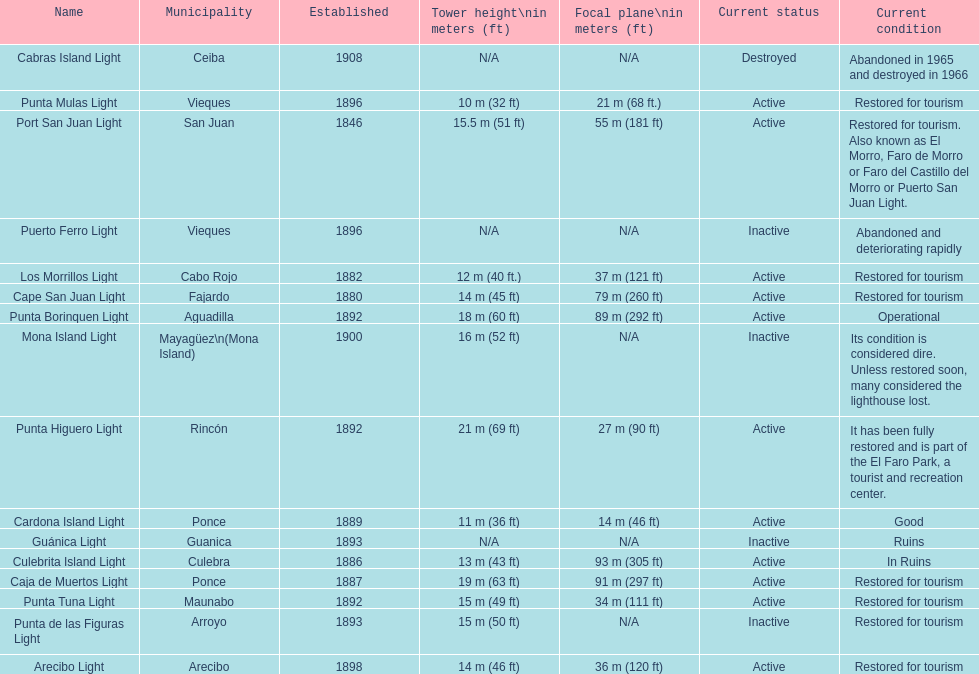Could you parse the entire table? {'header': ['Name', 'Municipality', 'Established', 'Tower height\\nin meters (ft)', 'Focal plane\\nin meters (ft)', 'Current status', 'Current condition'], 'rows': [['Cabras Island Light', 'Ceiba', '1908', 'N/A', 'N/A', 'Destroyed', 'Abandoned in 1965 and destroyed in 1966'], ['Punta Mulas Light', 'Vieques', '1896', '10\xa0m (32\xa0ft)', '21\xa0m (68\xa0ft.)', 'Active', 'Restored for tourism'], ['Port San Juan Light', 'San Juan', '1846', '15.5\xa0m (51\xa0ft)', '55\xa0m (181\xa0ft)', 'Active', 'Restored for tourism. Also known as El Morro, Faro de Morro or Faro del Castillo del Morro or Puerto San Juan Light.'], ['Puerto Ferro Light', 'Vieques', '1896', 'N/A', 'N/A', 'Inactive', 'Abandoned and deteriorating rapidly'], ['Los Morrillos Light', 'Cabo Rojo', '1882', '12\xa0m (40\xa0ft.)', '37\xa0m (121\xa0ft)', 'Active', 'Restored for tourism'], ['Cape San Juan Light', 'Fajardo', '1880', '14\xa0m (45\xa0ft)', '79\xa0m (260\xa0ft)', 'Active', 'Restored for tourism'], ['Punta Borinquen Light', 'Aguadilla', '1892', '18\xa0m (60\xa0ft)', '89\xa0m (292\xa0ft)', 'Active', 'Operational'], ['Mona Island Light', 'Mayagüez\\n(Mona Island)', '1900', '16\xa0m (52\xa0ft)', 'N/A', 'Inactive', 'Its condition is considered dire. Unless restored soon, many considered the lighthouse lost.'], ['Punta Higuero Light', 'Rincón', '1892', '21\xa0m (69\xa0ft)', '27\xa0m (90\xa0ft)', 'Active', 'It has been fully restored and is part of the El Faro Park, a tourist and recreation center.'], ['Cardona Island Light', 'Ponce', '1889', '11\xa0m (36\xa0ft)', '14\xa0m (46\xa0ft)', 'Active', 'Good'], ['Guánica Light', 'Guanica', '1893', 'N/A', 'N/A', 'Inactive', 'Ruins'], ['Culebrita Island Light', 'Culebra', '1886', '13\xa0m (43\xa0ft)', '93\xa0m (305\xa0ft)', 'Active', 'In Ruins'], ['Caja de Muertos Light', 'Ponce', '1887', '19\xa0m (63\xa0ft)', '91\xa0m (297\xa0ft)', 'Active', 'Restored for tourism'], ['Punta Tuna Light', 'Maunabo', '1892', '15\xa0m (49\xa0ft)', '34\xa0m (111\xa0ft)', 'Active', 'Restored for tourism'], ['Punta de las Figuras Light', 'Arroyo', '1893', '15\xa0m (50\xa0ft)', 'N/A', 'Inactive', 'Restored for tourism'], ['Arecibo Light', 'Arecibo', '1898', '14\xa0m (46\xa0ft)', '36\xa0m (120\xa0ft)', 'Active', 'Restored for tourism']]} How many towers are at least 18 meters tall? 3. 